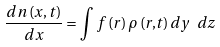Convert formula to latex. <formula><loc_0><loc_0><loc_500><loc_500>\frac { d n \left ( x , t \right ) } { d x } = \int f \left ( { r } \right ) \rho \left ( { r , } t \right ) d y \ d z</formula> 